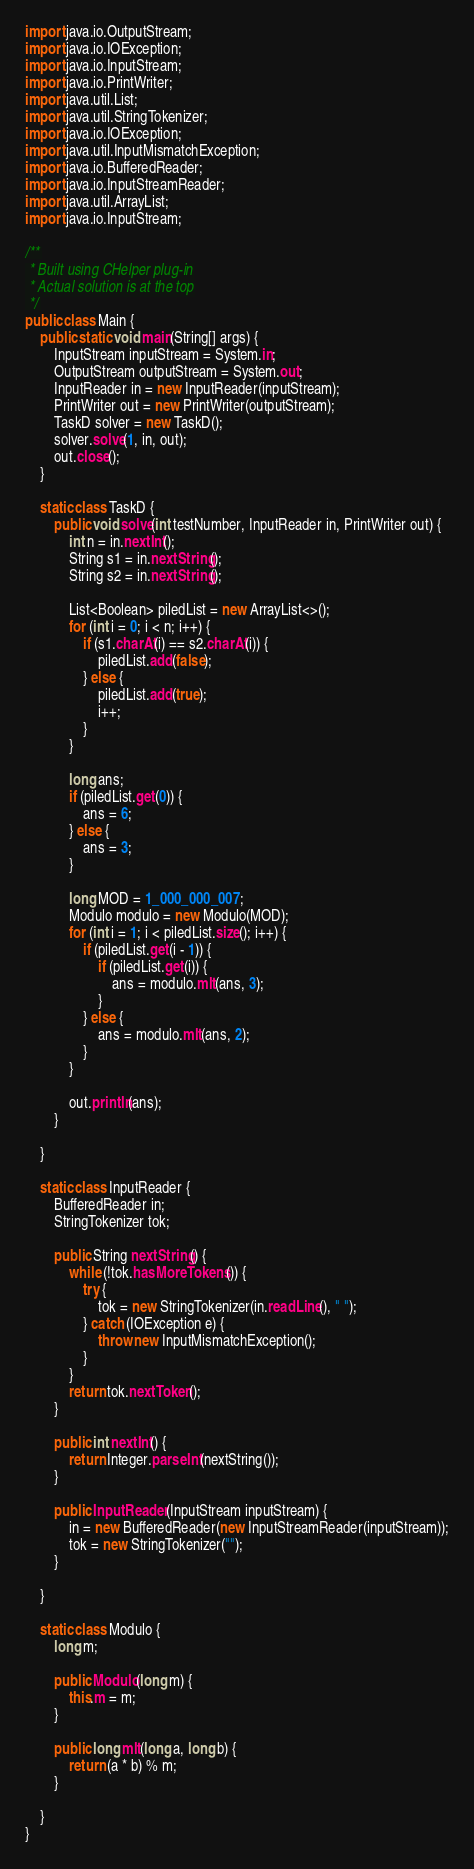<code> <loc_0><loc_0><loc_500><loc_500><_Java_>import java.io.OutputStream;
import java.io.IOException;
import java.io.InputStream;
import java.io.PrintWriter;
import java.util.List;
import java.util.StringTokenizer;
import java.io.IOException;
import java.util.InputMismatchException;
import java.io.BufferedReader;
import java.io.InputStreamReader;
import java.util.ArrayList;
import java.io.InputStream;

/**
 * Built using CHelper plug-in
 * Actual solution is at the top
 */
public class Main {
    public static void main(String[] args) {
        InputStream inputStream = System.in;
        OutputStream outputStream = System.out;
        InputReader in = new InputReader(inputStream);
        PrintWriter out = new PrintWriter(outputStream);
        TaskD solver = new TaskD();
        solver.solve(1, in, out);
        out.close();
    }

    static class TaskD {
        public void solve(int testNumber, InputReader in, PrintWriter out) {
            int n = in.nextInt();
            String s1 = in.nextString();
            String s2 = in.nextString();

            List<Boolean> piledList = new ArrayList<>();
            for (int i = 0; i < n; i++) {
                if (s1.charAt(i) == s2.charAt(i)) {
                    piledList.add(false);
                } else {
                    piledList.add(true);
                    i++;
                }
            }

            long ans;
            if (piledList.get(0)) {
                ans = 6;
            } else {
                ans = 3;
            }

            long MOD = 1_000_000_007;
            Modulo modulo = new Modulo(MOD);
            for (int i = 1; i < piledList.size(); i++) {
                if (piledList.get(i - 1)) {
                    if (piledList.get(i)) {
                        ans = modulo.mlt(ans, 3);
                    }
                } else {
                    ans = modulo.mlt(ans, 2);
                }
            }

            out.println(ans);
        }

    }

    static class InputReader {
        BufferedReader in;
        StringTokenizer tok;

        public String nextString() {
            while (!tok.hasMoreTokens()) {
                try {
                    tok = new StringTokenizer(in.readLine(), " ");
                } catch (IOException e) {
                    throw new InputMismatchException();
                }
            }
            return tok.nextToken();
        }

        public int nextInt() {
            return Integer.parseInt(nextString());
        }

        public InputReader(InputStream inputStream) {
            in = new BufferedReader(new InputStreamReader(inputStream));
            tok = new StringTokenizer("");
        }

    }

    static class Modulo {
        long m;

        public Modulo(long m) {
            this.m = m;
        }

        public long mlt(long a, long b) {
            return (a * b) % m;
        }

    }
}

</code> 